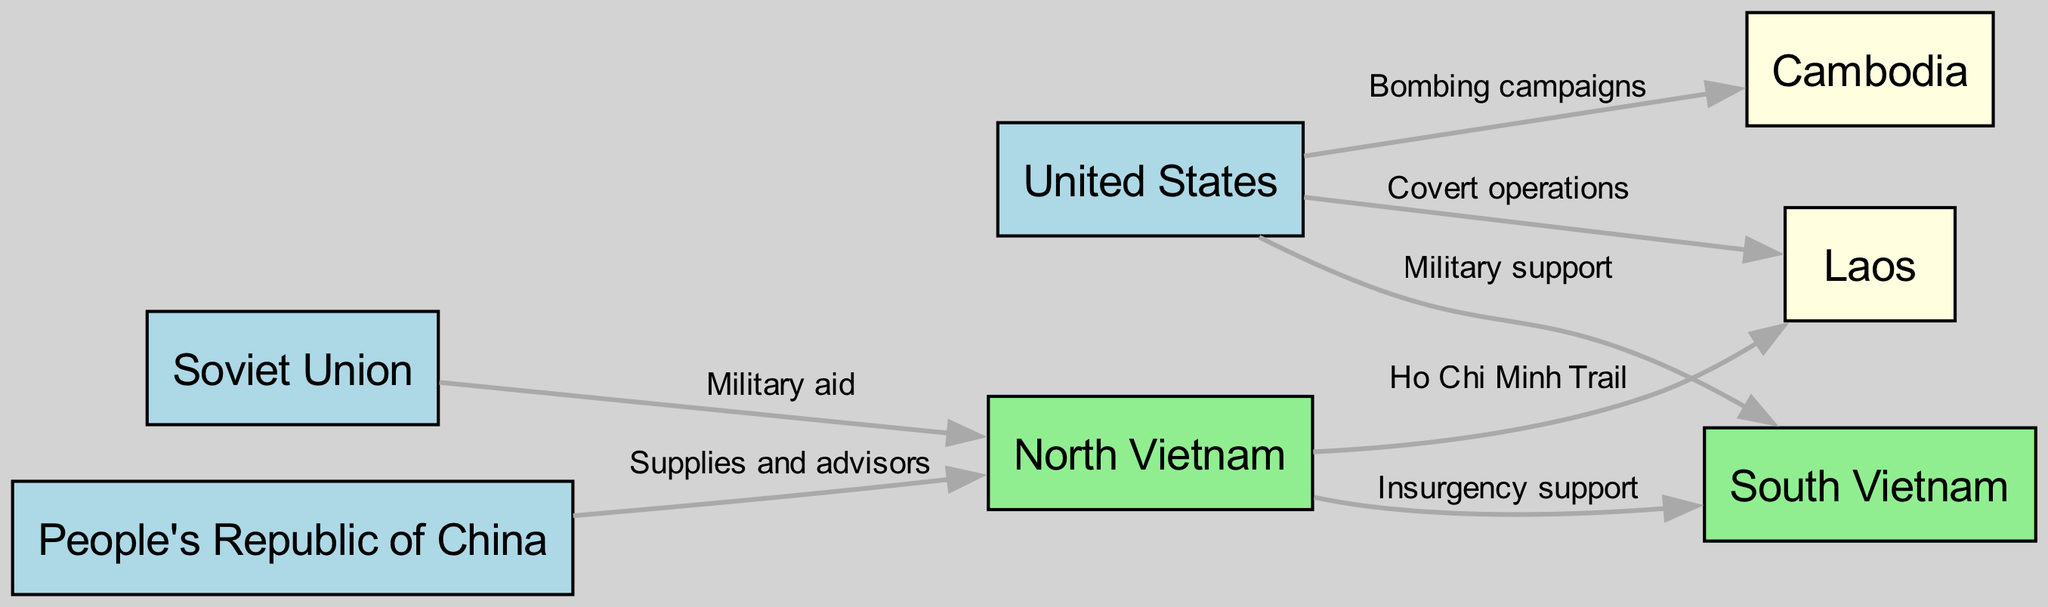What are the two primary nations providing military support to North Vietnam? From the diagram, we can identify North Vietnam which is connected to the Soviet Union with a labeled edge "Military aid" and also connected to China with the label "Supplies and advisors." Thus, the two primary nations providing military support to North Vietnam are the Soviet Union and China.
Answer: Soviet Union, China How many nodes are in total represented in the diagram? By counting the nodes listed in the diagram—United States, North Vietnam, South Vietnam, Soviet Union, China, Laos, and Cambodia—we find a total of 7 distinct entities.
Answer: 7 What type of support does the US provide to South Vietnam? Looking at the edge that connects the United States to South Vietnam, we see the label "Military support" which indicates the type of assistance being offered to South Vietnam from the United States.
Answer: Military support Which countries are linked to Laos, and what is the nature of that influence? The diagram shows that the United States has a connection to Laos labeled "Covert operations," while North Vietnam is connected to Laos via the "Ho Chi Minh Trail." This means that Laos is influenced by the US through covert operations and by North Vietnam as a transit route for logistical support.
Answer: United States, North Vietnam; Covert operations, Ho Chi Minh Trail What influences or support does North Vietnam provide to South Vietnam? From the diagram, we can observe an edge from North Vietnam to South Vietnam labeled "Insurgency support." This clearly indicates that North Vietnam is actively supporting insurgent activities within South Vietnam.
Answer: Insurgency support 